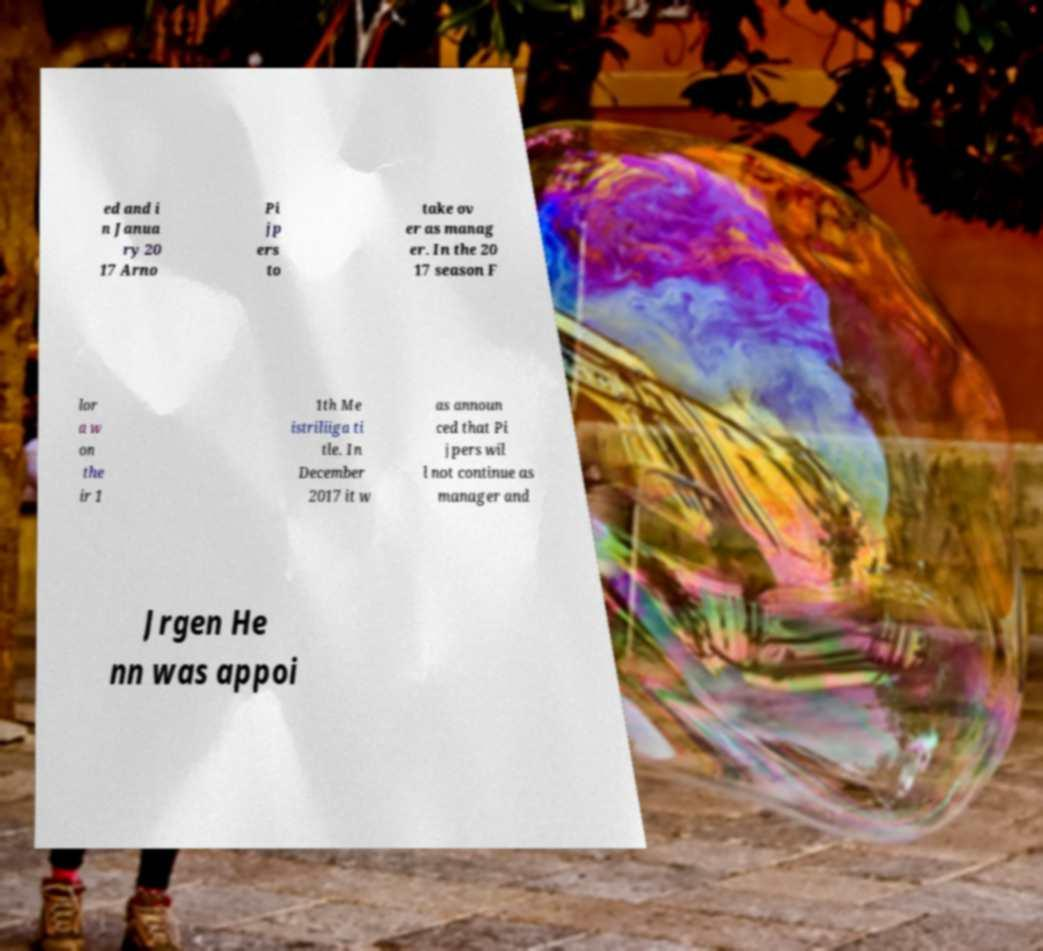I need the written content from this picture converted into text. Can you do that? ed and i n Janua ry 20 17 Arno Pi jp ers to take ov er as manag er. In the 20 17 season F lor a w on the ir 1 1th Me istriliiga ti tle. In December 2017 it w as announ ced that Pi jpers wil l not continue as manager and Jrgen He nn was appoi 